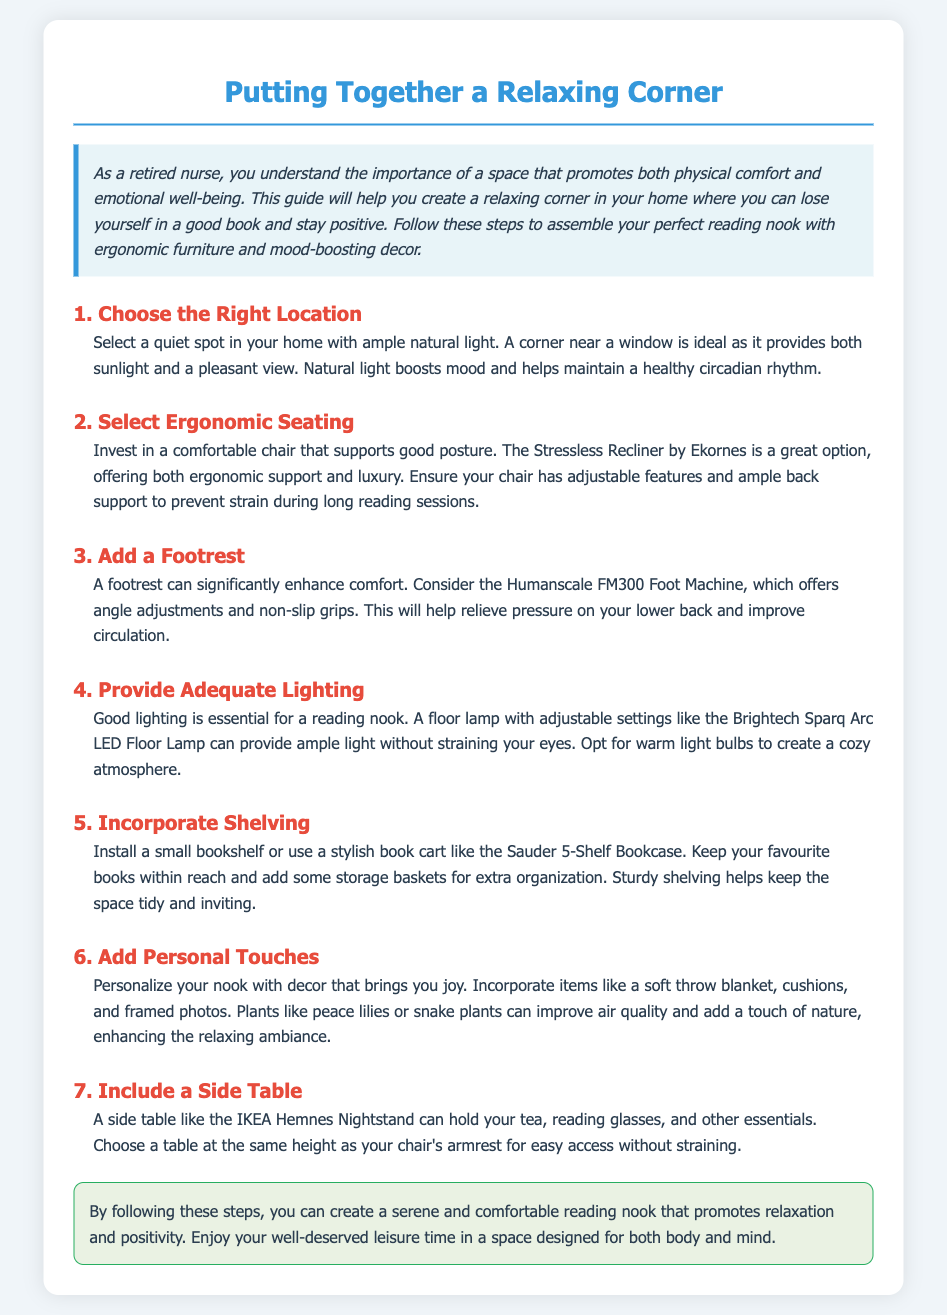What is the title of the guide? The title is presented at the top of the document, summarizing the content of the assembly instructions.
Answer: Putting Together a Relaxing Corner What should be chosen for the right location? The document specifies elements to consider when selecting a location for the reading nook.
Answer: A quiet spot with ample natural light Which chair is recommended for ergonomic seating? The document provides a specific option for ergonomic seating that supports good posture.
Answer: Stressless Recliner by Ekornes What type of lighting is essential for a reading nook? The guidelines mention the importance of lighting for the reading experience.
Answer: Good lighting What should be included to provide adequate comfort for your feet? The response indicates the type of accessory that enhances comfort in the reading nook.
Answer: A footrest What should be incorporated for personal touches? The assembly instructions emphasize adding personal decor items to the space.
Answer: Decor that brings joy How many steps are there in the assembly instructions? The total number of steps is given, guiding the user through the assembly process.
Answer: 7 What is the purpose of the relaxing corner? The document briefly describes the aim of creating the reading nook.
Answer: To promote relaxation and positivity 